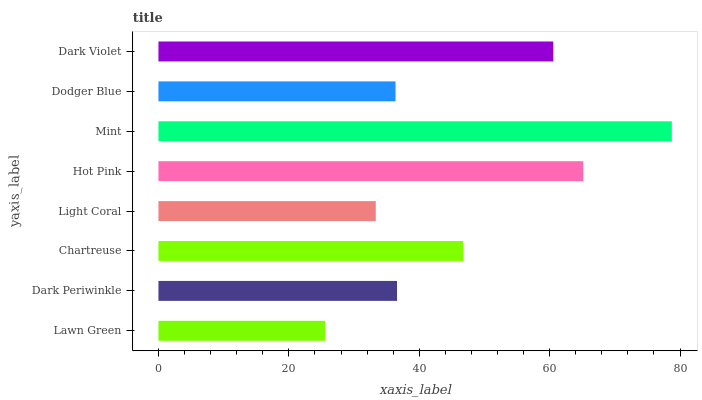Is Lawn Green the minimum?
Answer yes or no. Yes. Is Mint the maximum?
Answer yes or no. Yes. Is Dark Periwinkle the minimum?
Answer yes or no. No. Is Dark Periwinkle the maximum?
Answer yes or no. No. Is Dark Periwinkle greater than Lawn Green?
Answer yes or no. Yes. Is Lawn Green less than Dark Periwinkle?
Answer yes or no. Yes. Is Lawn Green greater than Dark Periwinkle?
Answer yes or no. No. Is Dark Periwinkle less than Lawn Green?
Answer yes or no. No. Is Chartreuse the high median?
Answer yes or no. Yes. Is Dark Periwinkle the low median?
Answer yes or no. Yes. Is Dodger Blue the high median?
Answer yes or no. No. Is Chartreuse the low median?
Answer yes or no. No. 